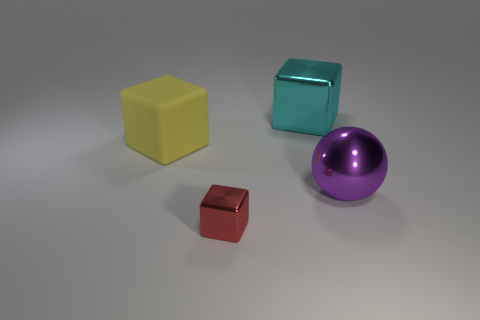Add 2 tiny red cubes. How many objects exist? 6 Subtract all blocks. How many objects are left? 1 Add 2 tiny red metal objects. How many tiny red metal objects exist? 3 Subtract 0 blue cylinders. How many objects are left? 4 Subtract all tiny gray metal blocks. Subtract all large metallic spheres. How many objects are left? 3 Add 4 big cyan metallic cubes. How many big cyan metallic cubes are left? 5 